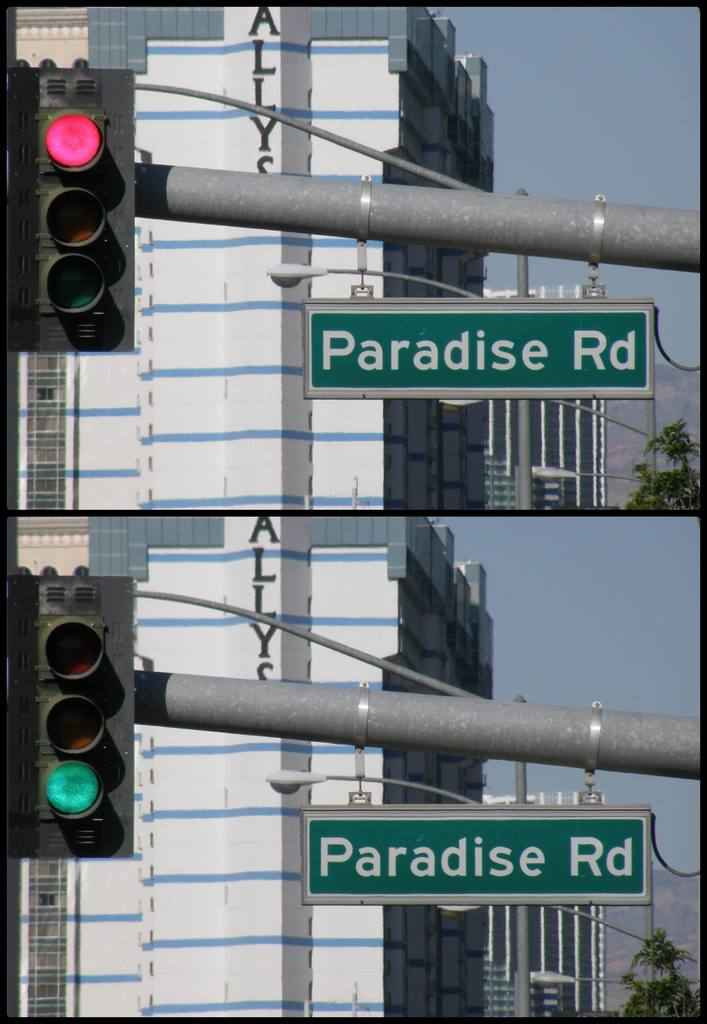Provide a one-sentence caption for the provided image. The image shows a traffic light in red phase atop two green road signs marked 'Paradise Rd', set against a backdrop of modern urban buildings under a clear sky. 